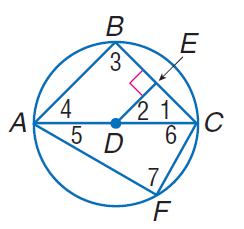Answer the mathemtical geometry problem and directly provide the correct option letter.
Question: In \odot D, D E \cong E C, m \widehat C F = 60, and D E \perp E C. Find m \angle 5.
Choices: A: 30 B: 30 C: 60 D: 90 A 